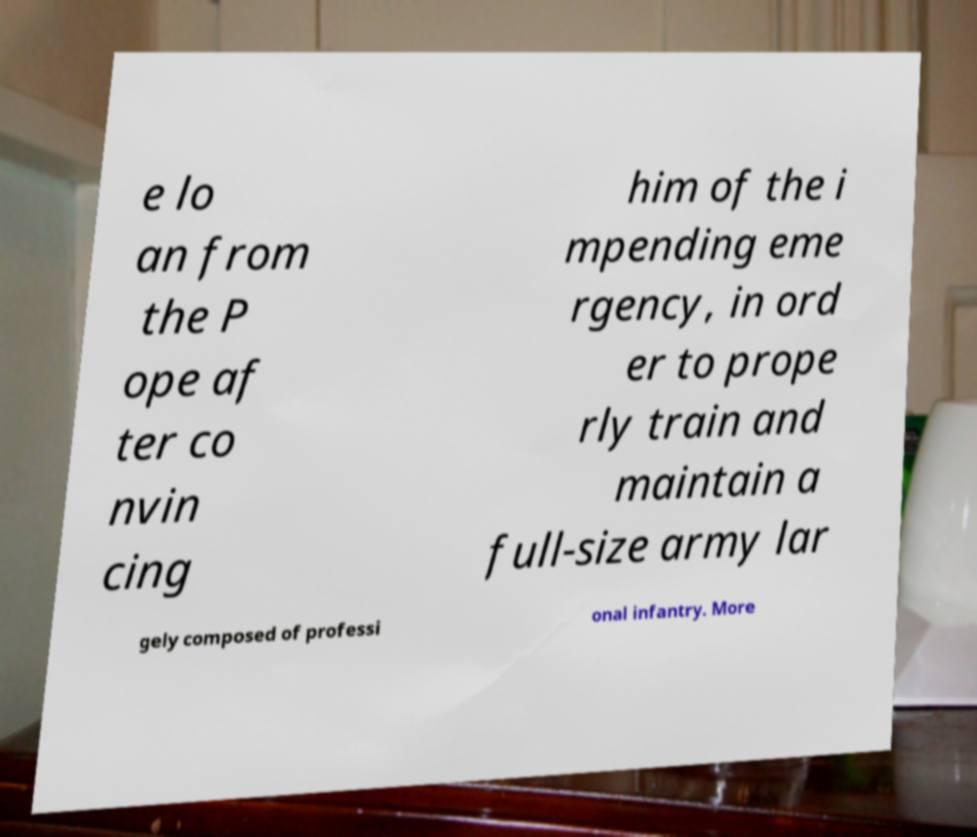Could you assist in decoding the text presented in this image and type it out clearly? e lo an from the P ope af ter co nvin cing him of the i mpending eme rgency, in ord er to prope rly train and maintain a full-size army lar gely composed of professi onal infantry. More 